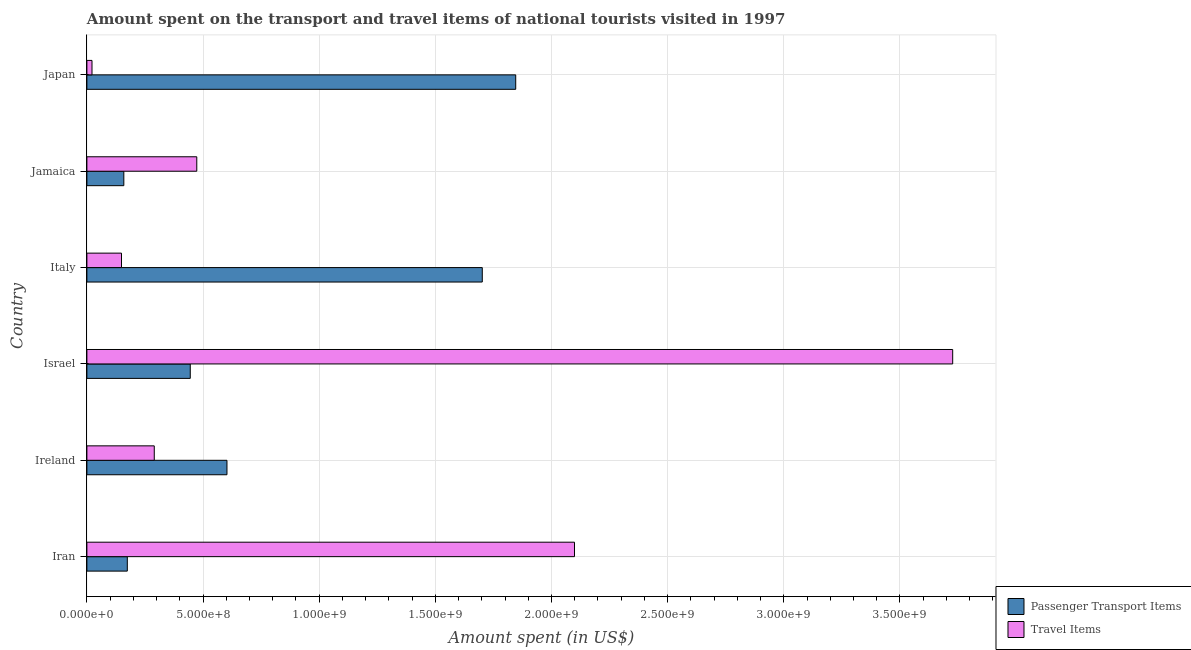Are the number of bars on each tick of the Y-axis equal?
Your answer should be very brief. Yes. How many bars are there on the 5th tick from the top?
Give a very brief answer. 2. What is the label of the 1st group of bars from the top?
Offer a very short reply. Japan. What is the amount spent in travel items in Israel?
Provide a succinct answer. 3.73e+09. Across all countries, what is the maximum amount spent on passenger transport items?
Give a very brief answer. 1.85e+09. Across all countries, what is the minimum amount spent in travel items?
Give a very brief answer. 2.20e+07. In which country was the amount spent in travel items maximum?
Provide a succinct answer. Israel. What is the total amount spent on passenger transport items in the graph?
Ensure brevity in your answer.  4.93e+09. What is the difference between the amount spent in travel items in Iran and that in Japan?
Keep it short and to the point. 2.08e+09. What is the difference between the amount spent in travel items in Jamaica and the amount spent on passenger transport items in Israel?
Ensure brevity in your answer.  2.80e+07. What is the average amount spent on passenger transport items per country?
Provide a short and direct response. 8.22e+08. What is the difference between the amount spent on passenger transport items and amount spent in travel items in Ireland?
Ensure brevity in your answer.  3.13e+08. What is the ratio of the amount spent on passenger transport items in Iran to that in Japan?
Provide a short and direct response. 0.09. What is the difference between the highest and the second highest amount spent in travel items?
Ensure brevity in your answer.  1.63e+09. What is the difference between the highest and the lowest amount spent on passenger transport items?
Provide a short and direct response. 1.69e+09. In how many countries, is the amount spent on passenger transport items greater than the average amount spent on passenger transport items taken over all countries?
Your response must be concise. 2. Is the sum of the amount spent in travel items in Israel and Jamaica greater than the maximum amount spent on passenger transport items across all countries?
Your answer should be very brief. Yes. What does the 2nd bar from the top in Israel represents?
Provide a short and direct response. Passenger Transport Items. What does the 2nd bar from the bottom in Ireland represents?
Offer a very short reply. Travel Items. How many bars are there?
Your response must be concise. 12. How many countries are there in the graph?
Ensure brevity in your answer.  6. Does the graph contain any zero values?
Your answer should be very brief. No. Does the graph contain grids?
Offer a very short reply. Yes. Where does the legend appear in the graph?
Make the answer very short. Bottom right. How are the legend labels stacked?
Provide a succinct answer. Vertical. What is the title of the graph?
Offer a very short reply. Amount spent on the transport and travel items of national tourists visited in 1997. What is the label or title of the X-axis?
Keep it short and to the point. Amount spent (in US$). What is the label or title of the Y-axis?
Provide a short and direct response. Country. What is the Amount spent (in US$) of Passenger Transport Items in Iran?
Offer a very short reply. 1.74e+08. What is the Amount spent (in US$) in Travel Items in Iran?
Your answer should be very brief. 2.10e+09. What is the Amount spent (in US$) of Passenger Transport Items in Ireland?
Give a very brief answer. 6.03e+08. What is the Amount spent (in US$) in Travel Items in Ireland?
Offer a very short reply. 2.90e+08. What is the Amount spent (in US$) of Passenger Transport Items in Israel?
Make the answer very short. 4.45e+08. What is the Amount spent (in US$) of Travel Items in Israel?
Your response must be concise. 3.73e+09. What is the Amount spent (in US$) in Passenger Transport Items in Italy?
Offer a terse response. 1.70e+09. What is the Amount spent (in US$) of Travel Items in Italy?
Ensure brevity in your answer.  1.49e+08. What is the Amount spent (in US$) of Passenger Transport Items in Jamaica?
Offer a terse response. 1.59e+08. What is the Amount spent (in US$) of Travel Items in Jamaica?
Keep it short and to the point. 4.73e+08. What is the Amount spent (in US$) of Passenger Transport Items in Japan?
Ensure brevity in your answer.  1.85e+09. What is the Amount spent (in US$) in Travel Items in Japan?
Your response must be concise. 2.20e+07. Across all countries, what is the maximum Amount spent (in US$) of Passenger Transport Items?
Your response must be concise. 1.85e+09. Across all countries, what is the maximum Amount spent (in US$) in Travel Items?
Provide a succinct answer. 3.73e+09. Across all countries, what is the minimum Amount spent (in US$) in Passenger Transport Items?
Keep it short and to the point. 1.59e+08. Across all countries, what is the minimum Amount spent (in US$) of Travel Items?
Offer a terse response. 2.20e+07. What is the total Amount spent (in US$) of Passenger Transport Items in the graph?
Provide a short and direct response. 4.93e+09. What is the total Amount spent (in US$) in Travel Items in the graph?
Provide a short and direct response. 6.76e+09. What is the difference between the Amount spent (in US$) of Passenger Transport Items in Iran and that in Ireland?
Offer a terse response. -4.29e+08. What is the difference between the Amount spent (in US$) of Travel Items in Iran and that in Ireland?
Provide a short and direct response. 1.81e+09. What is the difference between the Amount spent (in US$) of Passenger Transport Items in Iran and that in Israel?
Offer a terse response. -2.71e+08. What is the difference between the Amount spent (in US$) of Travel Items in Iran and that in Israel?
Make the answer very short. -1.63e+09. What is the difference between the Amount spent (in US$) of Passenger Transport Items in Iran and that in Italy?
Offer a terse response. -1.53e+09. What is the difference between the Amount spent (in US$) in Travel Items in Iran and that in Italy?
Keep it short and to the point. 1.95e+09. What is the difference between the Amount spent (in US$) in Passenger Transport Items in Iran and that in Jamaica?
Give a very brief answer. 1.50e+07. What is the difference between the Amount spent (in US$) of Travel Items in Iran and that in Jamaica?
Offer a very short reply. 1.63e+09. What is the difference between the Amount spent (in US$) in Passenger Transport Items in Iran and that in Japan?
Keep it short and to the point. -1.67e+09. What is the difference between the Amount spent (in US$) in Travel Items in Iran and that in Japan?
Offer a terse response. 2.08e+09. What is the difference between the Amount spent (in US$) in Passenger Transport Items in Ireland and that in Israel?
Your answer should be very brief. 1.58e+08. What is the difference between the Amount spent (in US$) of Travel Items in Ireland and that in Israel?
Ensure brevity in your answer.  -3.44e+09. What is the difference between the Amount spent (in US$) in Passenger Transport Items in Ireland and that in Italy?
Your answer should be compact. -1.10e+09. What is the difference between the Amount spent (in US$) in Travel Items in Ireland and that in Italy?
Provide a short and direct response. 1.41e+08. What is the difference between the Amount spent (in US$) of Passenger Transport Items in Ireland and that in Jamaica?
Your response must be concise. 4.44e+08. What is the difference between the Amount spent (in US$) in Travel Items in Ireland and that in Jamaica?
Offer a very short reply. -1.83e+08. What is the difference between the Amount spent (in US$) of Passenger Transport Items in Ireland and that in Japan?
Ensure brevity in your answer.  -1.24e+09. What is the difference between the Amount spent (in US$) of Travel Items in Ireland and that in Japan?
Offer a terse response. 2.68e+08. What is the difference between the Amount spent (in US$) of Passenger Transport Items in Israel and that in Italy?
Provide a short and direct response. -1.26e+09. What is the difference between the Amount spent (in US$) of Travel Items in Israel and that in Italy?
Your answer should be very brief. 3.58e+09. What is the difference between the Amount spent (in US$) in Passenger Transport Items in Israel and that in Jamaica?
Offer a terse response. 2.86e+08. What is the difference between the Amount spent (in US$) of Travel Items in Israel and that in Jamaica?
Give a very brief answer. 3.25e+09. What is the difference between the Amount spent (in US$) in Passenger Transport Items in Israel and that in Japan?
Offer a terse response. -1.40e+09. What is the difference between the Amount spent (in US$) in Travel Items in Israel and that in Japan?
Provide a succinct answer. 3.70e+09. What is the difference between the Amount spent (in US$) in Passenger Transport Items in Italy and that in Jamaica?
Give a very brief answer. 1.54e+09. What is the difference between the Amount spent (in US$) in Travel Items in Italy and that in Jamaica?
Keep it short and to the point. -3.24e+08. What is the difference between the Amount spent (in US$) in Passenger Transport Items in Italy and that in Japan?
Keep it short and to the point. -1.44e+08. What is the difference between the Amount spent (in US$) of Travel Items in Italy and that in Japan?
Your answer should be compact. 1.27e+08. What is the difference between the Amount spent (in US$) of Passenger Transport Items in Jamaica and that in Japan?
Provide a succinct answer. -1.69e+09. What is the difference between the Amount spent (in US$) of Travel Items in Jamaica and that in Japan?
Offer a very short reply. 4.51e+08. What is the difference between the Amount spent (in US$) of Passenger Transport Items in Iran and the Amount spent (in US$) of Travel Items in Ireland?
Provide a succinct answer. -1.16e+08. What is the difference between the Amount spent (in US$) in Passenger Transport Items in Iran and the Amount spent (in US$) in Travel Items in Israel?
Ensure brevity in your answer.  -3.55e+09. What is the difference between the Amount spent (in US$) in Passenger Transport Items in Iran and the Amount spent (in US$) in Travel Items in Italy?
Keep it short and to the point. 2.50e+07. What is the difference between the Amount spent (in US$) of Passenger Transport Items in Iran and the Amount spent (in US$) of Travel Items in Jamaica?
Ensure brevity in your answer.  -2.99e+08. What is the difference between the Amount spent (in US$) in Passenger Transport Items in Iran and the Amount spent (in US$) in Travel Items in Japan?
Offer a terse response. 1.52e+08. What is the difference between the Amount spent (in US$) in Passenger Transport Items in Ireland and the Amount spent (in US$) in Travel Items in Israel?
Provide a short and direct response. -3.12e+09. What is the difference between the Amount spent (in US$) in Passenger Transport Items in Ireland and the Amount spent (in US$) in Travel Items in Italy?
Your answer should be very brief. 4.54e+08. What is the difference between the Amount spent (in US$) of Passenger Transport Items in Ireland and the Amount spent (in US$) of Travel Items in Jamaica?
Offer a very short reply. 1.30e+08. What is the difference between the Amount spent (in US$) of Passenger Transport Items in Ireland and the Amount spent (in US$) of Travel Items in Japan?
Ensure brevity in your answer.  5.81e+08. What is the difference between the Amount spent (in US$) in Passenger Transport Items in Israel and the Amount spent (in US$) in Travel Items in Italy?
Provide a succinct answer. 2.96e+08. What is the difference between the Amount spent (in US$) in Passenger Transport Items in Israel and the Amount spent (in US$) in Travel Items in Jamaica?
Your answer should be very brief. -2.80e+07. What is the difference between the Amount spent (in US$) of Passenger Transport Items in Israel and the Amount spent (in US$) of Travel Items in Japan?
Offer a terse response. 4.23e+08. What is the difference between the Amount spent (in US$) of Passenger Transport Items in Italy and the Amount spent (in US$) of Travel Items in Jamaica?
Provide a succinct answer. 1.23e+09. What is the difference between the Amount spent (in US$) in Passenger Transport Items in Italy and the Amount spent (in US$) in Travel Items in Japan?
Your response must be concise. 1.68e+09. What is the difference between the Amount spent (in US$) in Passenger Transport Items in Jamaica and the Amount spent (in US$) in Travel Items in Japan?
Provide a succinct answer. 1.37e+08. What is the average Amount spent (in US$) of Passenger Transport Items per country?
Ensure brevity in your answer.  8.22e+08. What is the average Amount spent (in US$) in Travel Items per country?
Ensure brevity in your answer.  1.13e+09. What is the difference between the Amount spent (in US$) in Passenger Transport Items and Amount spent (in US$) in Travel Items in Iran?
Offer a terse response. -1.92e+09. What is the difference between the Amount spent (in US$) of Passenger Transport Items and Amount spent (in US$) of Travel Items in Ireland?
Give a very brief answer. 3.13e+08. What is the difference between the Amount spent (in US$) in Passenger Transport Items and Amount spent (in US$) in Travel Items in Israel?
Offer a terse response. -3.28e+09. What is the difference between the Amount spent (in US$) of Passenger Transport Items and Amount spent (in US$) of Travel Items in Italy?
Offer a very short reply. 1.55e+09. What is the difference between the Amount spent (in US$) of Passenger Transport Items and Amount spent (in US$) of Travel Items in Jamaica?
Your response must be concise. -3.14e+08. What is the difference between the Amount spent (in US$) in Passenger Transport Items and Amount spent (in US$) in Travel Items in Japan?
Provide a succinct answer. 1.82e+09. What is the ratio of the Amount spent (in US$) of Passenger Transport Items in Iran to that in Ireland?
Provide a succinct answer. 0.29. What is the ratio of the Amount spent (in US$) of Travel Items in Iran to that in Ireland?
Make the answer very short. 7.24. What is the ratio of the Amount spent (in US$) in Passenger Transport Items in Iran to that in Israel?
Your answer should be compact. 0.39. What is the ratio of the Amount spent (in US$) of Travel Items in Iran to that in Israel?
Offer a very short reply. 0.56. What is the ratio of the Amount spent (in US$) in Passenger Transport Items in Iran to that in Italy?
Keep it short and to the point. 0.1. What is the ratio of the Amount spent (in US$) of Travel Items in Iran to that in Italy?
Keep it short and to the point. 14.09. What is the ratio of the Amount spent (in US$) in Passenger Transport Items in Iran to that in Jamaica?
Offer a terse response. 1.09. What is the ratio of the Amount spent (in US$) in Travel Items in Iran to that in Jamaica?
Provide a succinct answer. 4.44. What is the ratio of the Amount spent (in US$) of Passenger Transport Items in Iran to that in Japan?
Your response must be concise. 0.09. What is the ratio of the Amount spent (in US$) of Travel Items in Iran to that in Japan?
Offer a very short reply. 95.41. What is the ratio of the Amount spent (in US$) of Passenger Transport Items in Ireland to that in Israel?
Make the answer very short. 1.36. What is the ratio of the Amount spent (in US$) in Travel Items in Ireland to that in Israel?
Your response must be concise. 0.08. What is the ratio of the Amount spent (in US$) of Passenger Transport Items in Ireland to that in Italy?
Offer a terse response. 0.35. What is the ratio of the Amount spent (in US$) in Travel Items in Ireland to that in Italy?
Offer a terse response. 1.95. What is the ratio of the Amount spent (in US$) of Passenger Transport Items in Ireland to that in Jamaica?
Offer a very short reply. 3.79. What is the ratio of the Amount spent (in US$) of Travel Items in Ireland to that in Jamaica?
Your answer should be very brief. 0.61. What is the ratio of the Amount spent (in US$) in Passenger Transport Items in Ireland to that in Japan?
Give a very brief answer. 0.33. What is the ratio of the Amount spent (in US$) of Travel Items in Ireland to that in Japan?
Your response must be concise. 13.18. What is the ratio of the Amount spent (in US$) in Passenger Transport Items in Israel to that in Italy?
Keep it short and to the point. 0.26. What is the ratio of the Amount spent (in US$) in Travel Items in Israel to that in Italy?
Provide a short and direct response. 25.01. What is the ratio of the Amount spent (in US$) of Passenger Transport Items in Israel to that in Jamaica?
Ensure brevity in your answer.  2.8. What is the ratio of the Amount spent (in US$) in Travel Items in Israel to that in Jamaica?
Your response must be concise. 7.88. What is the ratio of the Amount spent (in US$) of Passenger Transport Items in Israel to that in Japan?
Offer a terse response. 0.24. What is the ratio of the Amount spent (in US$) of Travel Items in Israel to that in Japan?
Keep it short and to the point. 169.41. What is the ratio of the Amount spent (in US$) of Passenger Transport Items in Italy to that in Jamaica?
Ensure brevity in your answer.  10.7. What is the ratio of the Amount spent (in US$) in Travel Items in Italy to that in Jamaica?
Your response must be concise. 0.32. What is the ratio of the Amount spent (in US$) of Passenger Transport Items in Italy to that in Japan?
Provide a succinct answer. 0.92. What is the ratio of the Amount spent (in US$) in Travel Items in Italy to that in Japan?
Give a very brief answer. 6.77. What is the ratio of the Amount spent (in US$) of Passenger Transport Items in Jamaica to that in Japan?
Your answer should be very brief. 0.09. What is the ratio of the Amount spent (in US$) in Travel Items in Jamaica to that in Japan?
Ensure brevity in your answer.  21.5. What is the difference between the highest and the second highest Amount spent (in US$) of Passenger Transport Items?
Keep it short and to the point. 1.44e+08. What is the difference between the highest and the second highest Amount spent (in US$) of Travel Items?
Make the answer very short. 1.63e+09. What is the difference between the highest and the lowest Amount spent (in US$) in Passenger Transport Items?
Keep it short and to the point. 1.69e+09. What is the difference between the highest and the lowest Amount spent (in US$) of Travel Items?
Offer a terse response. 3.70e+09. 